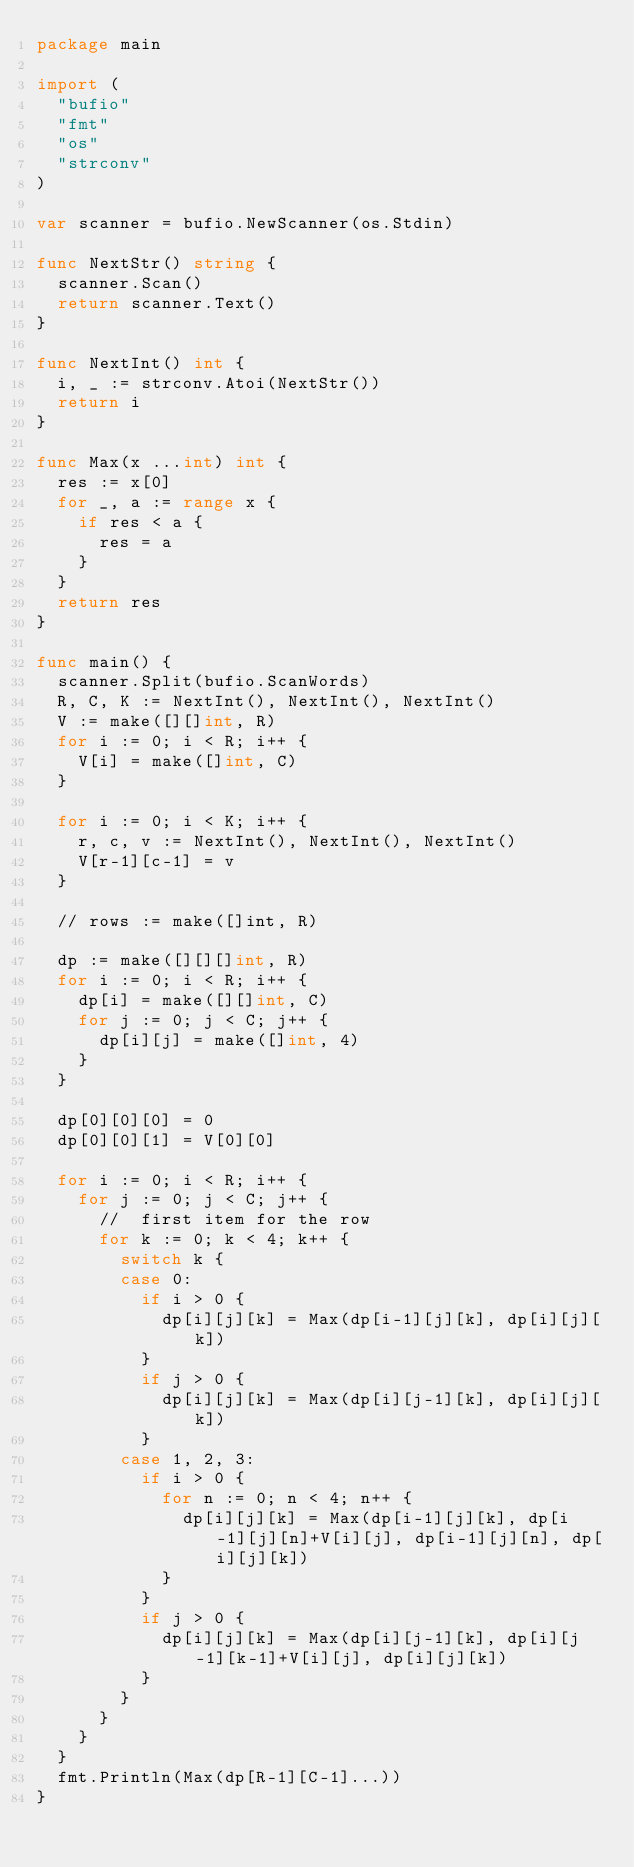<code> <loc_0><loc_0><loc_500><loc_500><_Go_>package main

import (
	"bufio"
	"fmt"
	"os"
	"strconv"
)

var scanner = bufio.NewScanner(os.Stdin)

func NextStr() string {
	scanner.Scan()
	return scanner.Text()
}

func NextInt() int {
	i, _ := strconv.Atoi(NextStr())
	return i
}

func Max(x ...int) int {
	res := x[0]
	for _, a := range x {
		if res < a {
			res = a
		}
	}
	return res
}

func main() {
	scanner.Split(bufio.ScanWords)
	R, C, K := NextInt(), NextInt(), NextInt()
	V := make([][]int, R)
	for i := 0; i < R; i++ {
		V[i] = make([]int, C)
	}

	for i := 0; i < K; i++ {
		r, c, v := NextInt(), NextInt(), NextInt()
		V[r-1][c-1] = v
	}

	// rows := make([]int, R)

	dp := make([][][]int, R)
	for i := 0; i < R; i++ {
		dp[i] = make([][]int, C)
		for j := 0; j < C; j++ {
			dp[i][j] = make([]int, 4)
		}
	}

	dp[0][0][0] = 0
	dp[0][0][1] = V[0][0]

	for i := 0; i < R; i++ {
		for j := 0; j < C; j++ {
			//  first item for the row
			for k := 0; k < 4; k++ {
				switch k {
				case 0:
					if i > 0 {
						dp[i][j][k] = Max(dp[i-1][j][k], dp[i][j][k])
					}
					if j > 0 {
						dp[i][j][k] = Max(dp[i][j-1][k], dp[i][j][k])
					}
				case 1, 2, 3:
					if i > 0 {
						for n := 0; n < 4; n++ {
							dp[i][j][k] = Max(dp[i-1][j][k], dp[i-1][j][n]+V[i][j], dp[i-1][j][n], dp[i][j][k])
						}
					}
					if j > 0 {
						dp[i][j][k] = Max(dp[i][j-1][k], dp[i][j-1][k-1]+V[i][j], dp[i][j][k])
					}
				}
			}
		}
	}
	fmt.Println(Max(dp[R-1][C-1]...))
}
</code> 